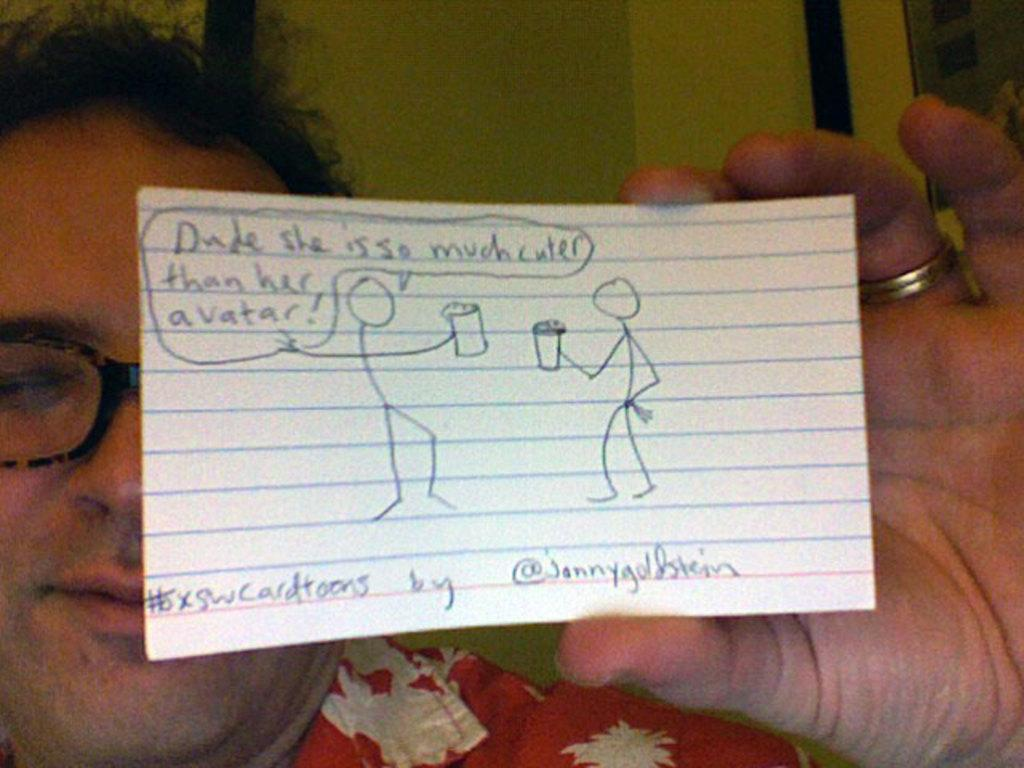What can be seen in the image? There is a person in the image. What is the person wearing? The person is wearing a red shirt and spectacles. What is the person holding? The person is holding a paper. What can be observed on the paper? There is text written on the paper. What is visible in the background of the image? There is a wall in the background of the image. What type of vegetable is the person growing in the image? There is no vegetable present in the image; it features a person holding a paper with text. How much profit is the person making from the trees in the image? There are no trees or mention of profit in the image; it only shows a person holding a paper with text and a wall in the background. 